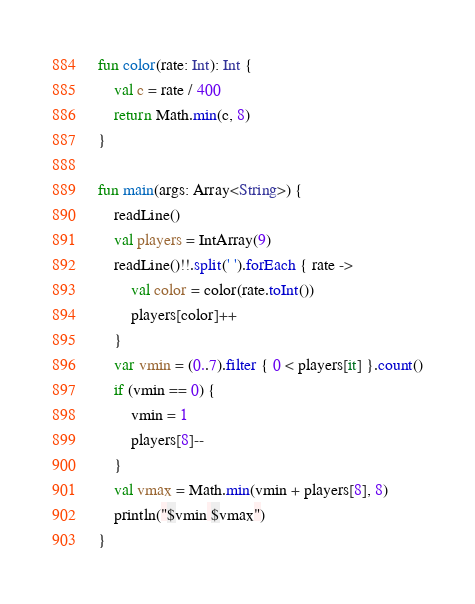Convert code to text. <code><loc_0><loc_0><loc_500><loc_500><_Kotlin_>fun color(rate: Int): Int {
    val c = rate / 400
    return Math.min(c, 8)
}

fun main(args: Array<String>) {
    readLine()
    val players = IntArray(9)
    readLine()!!.split(' ').forEach { rate ->
        val color = color(rate.toInt())
        players[color]++
    }
    var vmin = (0..7).filter { 0 < players[it] }.count()
    if (vmin == 0) {
        vmin = 1
        players[8]--
    }
    val vmax = Math.min(vmin + players[8], 8)
    println("$vmin $vmax")
}
</code> 